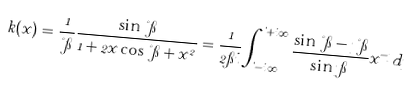<formula> <loc_0><loc_0><loc_500><loc_500>k ( x ) = \frac { 1 } { \nu \pi } \frac { \sin \nu \pi } { 1 + 2 x \cos \nu \pi + x ^ { 2 } } = \frac { 1 } { 2 \pi i } \int _ { \theta - i \infty } ^ { \theta + i \infty } \frac { \sin \nu \pi - \eta \nu \pi } { \sin \eta \pi } x ^ { - \eta } d \eta</formula> 